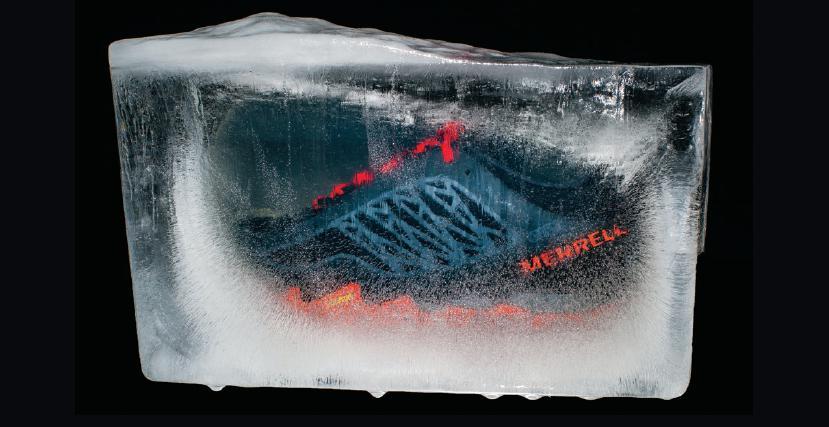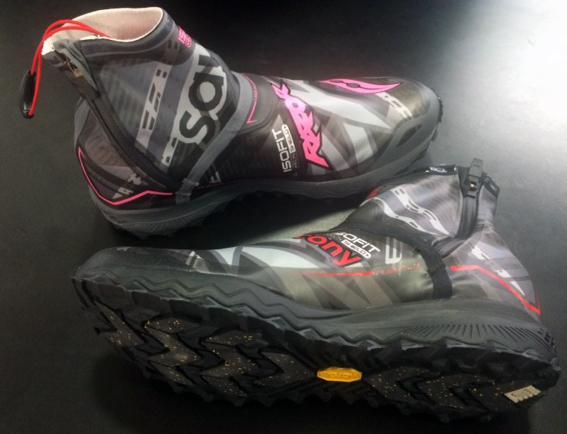The first image is the image on the left, the second image is the image on the right. Analyze the images presented: Is the assertion "there is humans in the right side image" valid? Answer yes or no. No. The first image is the image on the left, the second image is the image on the right. Evaluate the accuracy of this statement regarding the images: "There are two people running on the pavement.". Is it true? Answer yes or no. No. The first image is the image on the left, the second image is the image on the right. Evaluate the accuracy of this statement regarding the images: "There is an image of a single shoe pointing to the right.". Is it true? Answer yes or no. No. The first image is the image on the left, the second image is the image on the right. Considering the images on both sides, is "In one image there are two people running outside with snow on the ground." valid? Answer yes or no. No. 